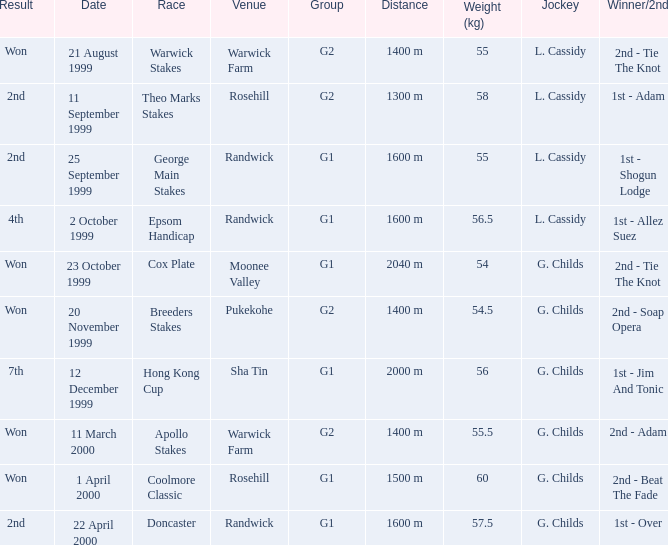Indicate the weightiness for 5 Epsom Handicap. 